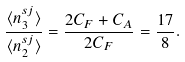Convert formula to latex. <formula><loc_0><loc_0><loc_500><loc_500>\frac { \langle n _ { 3 } ^ { s j } \rangle } { \langle n _ { 2 } ^ { s j } \rangle } = \frac { 2 C _ { F } + C _ { A } } { 2 C _ { F } } = \frac { 1 7 } { 8 } .</formula> 